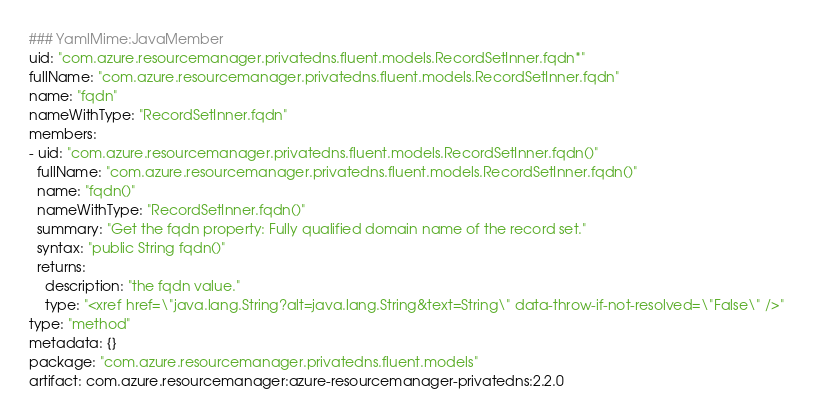<code> <loc_0><loc_0><loc_500><loc_500><_YAML_>### YamlMime:JavaMember
uid: "com.azure.resourcemanager.privatedns.fluent.models.RecordSetInner.fqdn*"
fullName: "com.azure.resourcemanager.privatedns.fluent.models.RecordSetInner.fqdn"
name: "fqdn"
nameWithType: "RecordSetInner.fqdn"
members:
- uid: "com.azure.resourcemanager.privatedns.fluent.models.RecordSetInner.fqdn()"
  fullName: "com.azure.resourcemanager.privatedns.fluent.models.RecordSetInner.fqdn()"
  name: "fqdn()"
  nameWithType: "RecordSetInner.fqdn()"
  summary: "Get the fqdn property: Fully qualified domain name of the record set."
  syntax: "public String fqdn()"
  returns:
    description: "the fqdn value."
    type: "<xref href=\"java.lang.String?alt=java.lang.String&text=String\" data-throw-if-not-resolved=\"False\" />"
type: "method"
metadata: {}
package: "com.azure.resourcemanager.privatedns.fluent.models"
artifact: com.azure.resourcemanager:azure-resourcemanager-privatedns:2.2.0
</code> 